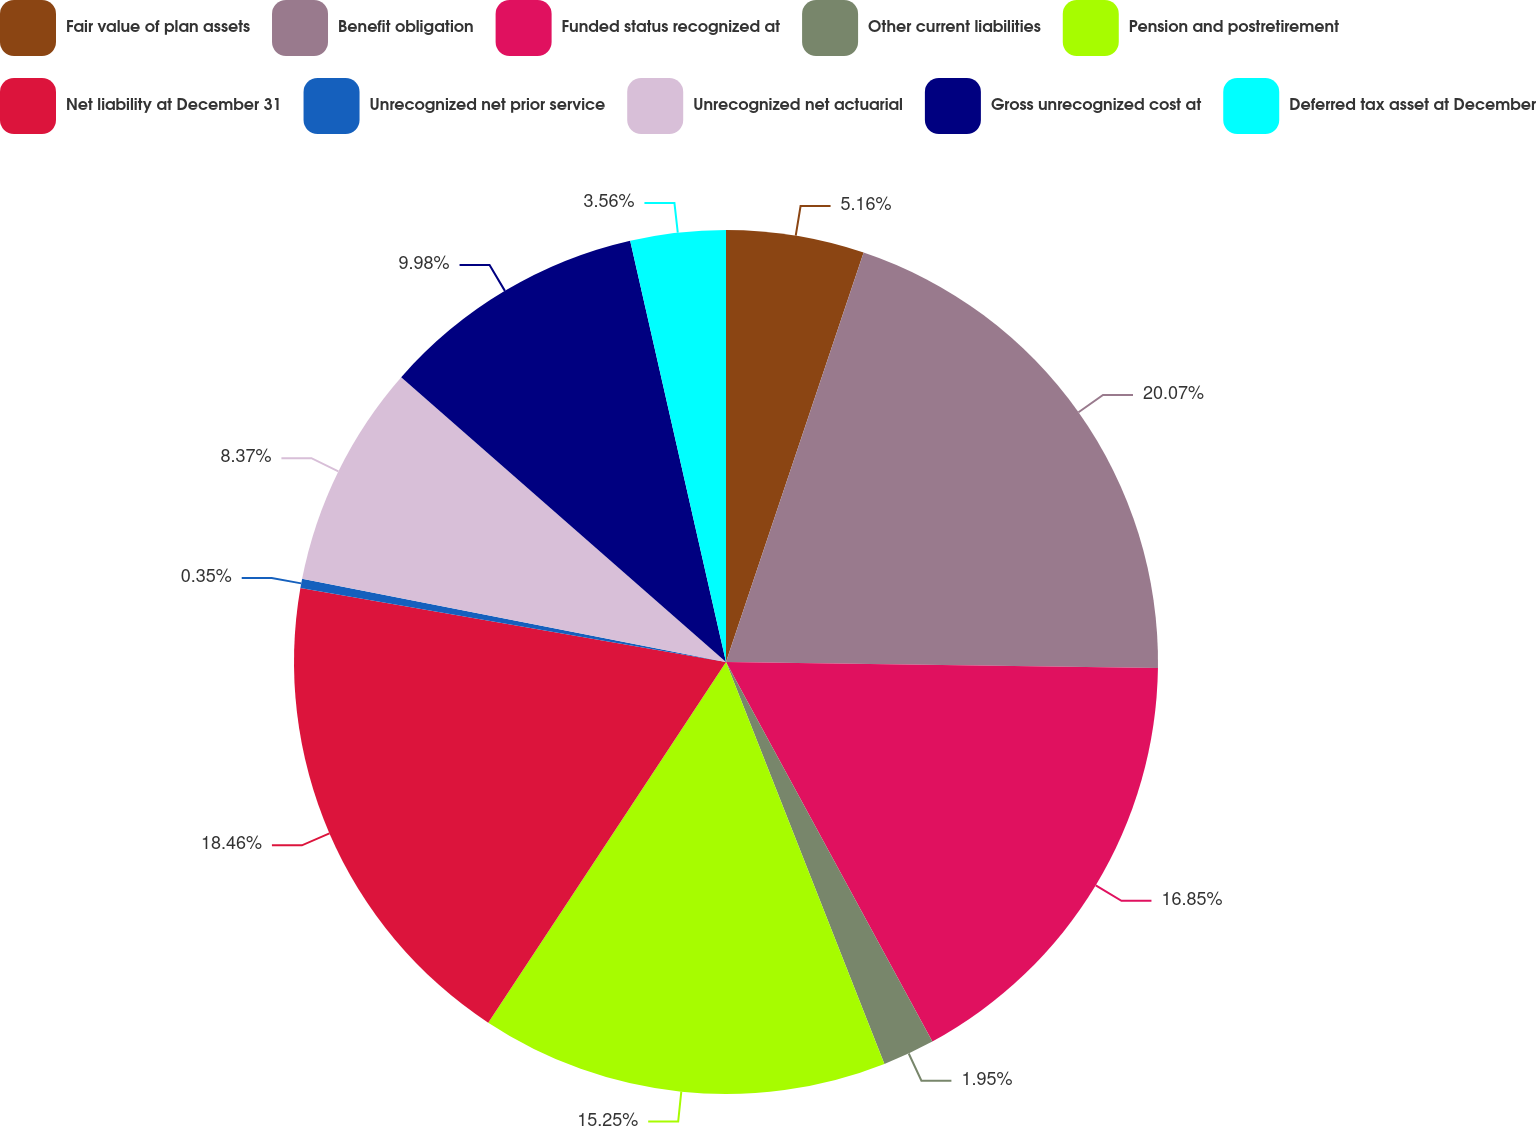<chart> <loc_0><loc_0><loc_500><loc_500><pie_chart><fcel>Fair value of plan assets<fcel>Benefit obligation<fcel>Funded status recognized at<fcel>Other current liabilities<fcel>Pension and postretirement<fcel>Net liability at December 31<fcel>Unrecognized net prior service<fcel>Unrecognized net actuarial<fcel>Gross unrecognized cost at<fcel>Deferred tax asset at December<nl><fcel>5.16%<fcel>20.06%<fcel>16.85%<fcel>1.95%<fcel>15.25%<fcel>18.46%<fcel>0.35%<fcel>8.37%<fcel>9.98%<fcel>3.56%<nl></chart> 